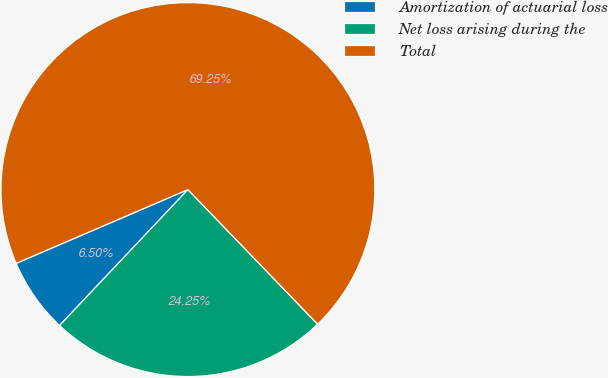Convert chart. <chart><loc_0><loc_0><loc_500><loc_500><pie_chart><fcel>Amortization of actuarial loss<fcel>Net loss arising during the<fcel>Total<nl><fcel>6.5%<fcel>24.25%<fcel>69.26%<nl></chart> 